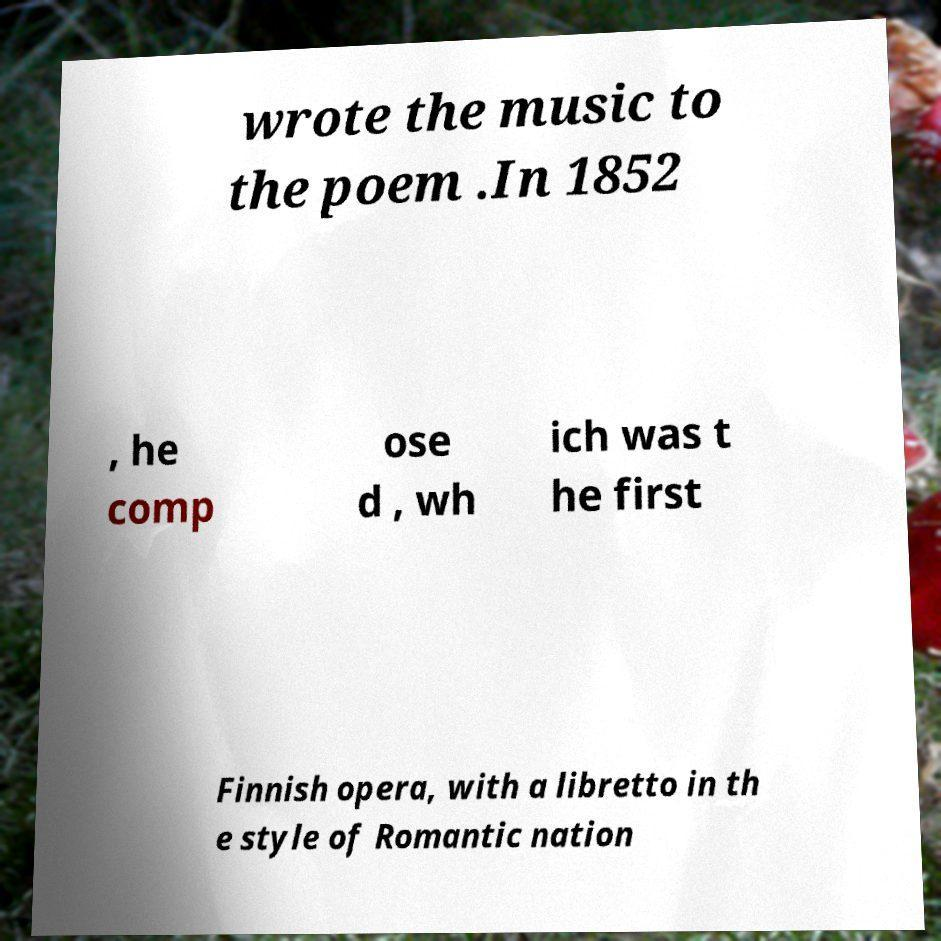Could you extract and type out the text from this image? wrote the music to the poem .In 1852 , he comp ose d , wh ich was t he first Finnish opera, with a libretto in th e style of Romantic nation 